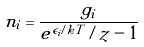<formula> <loc_0><loc_0><loc_500><loc_500>n _ { i } = \frac { g _ { i } } { e ^ { \epsilon _ { i } / k T } / z - 1 }</formula> 